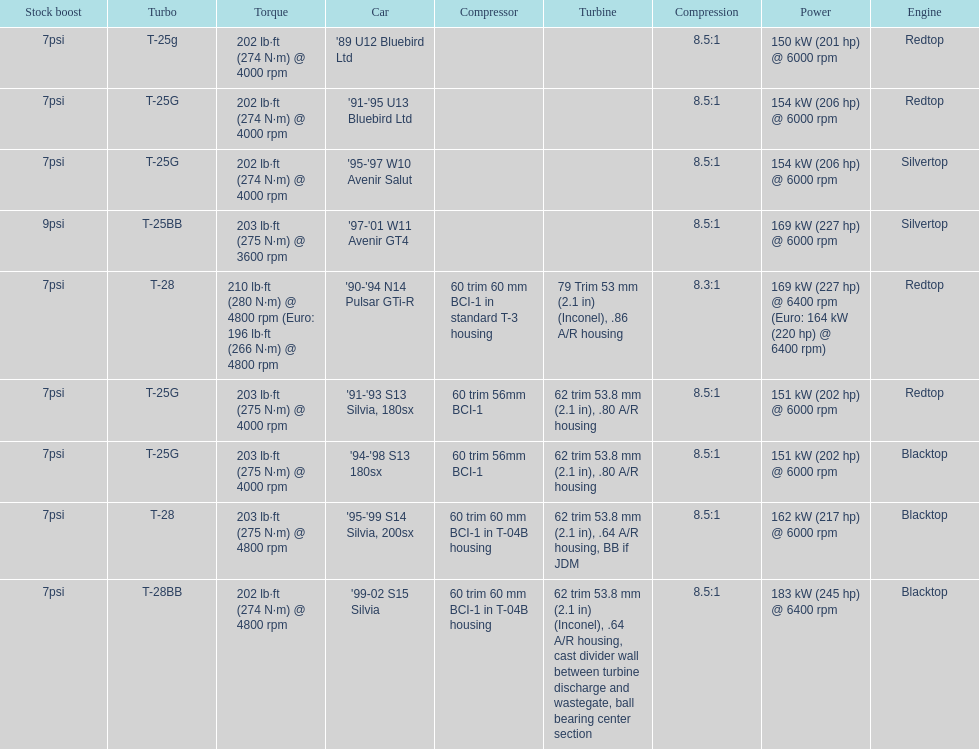How many models used the redtop engine? 4. 